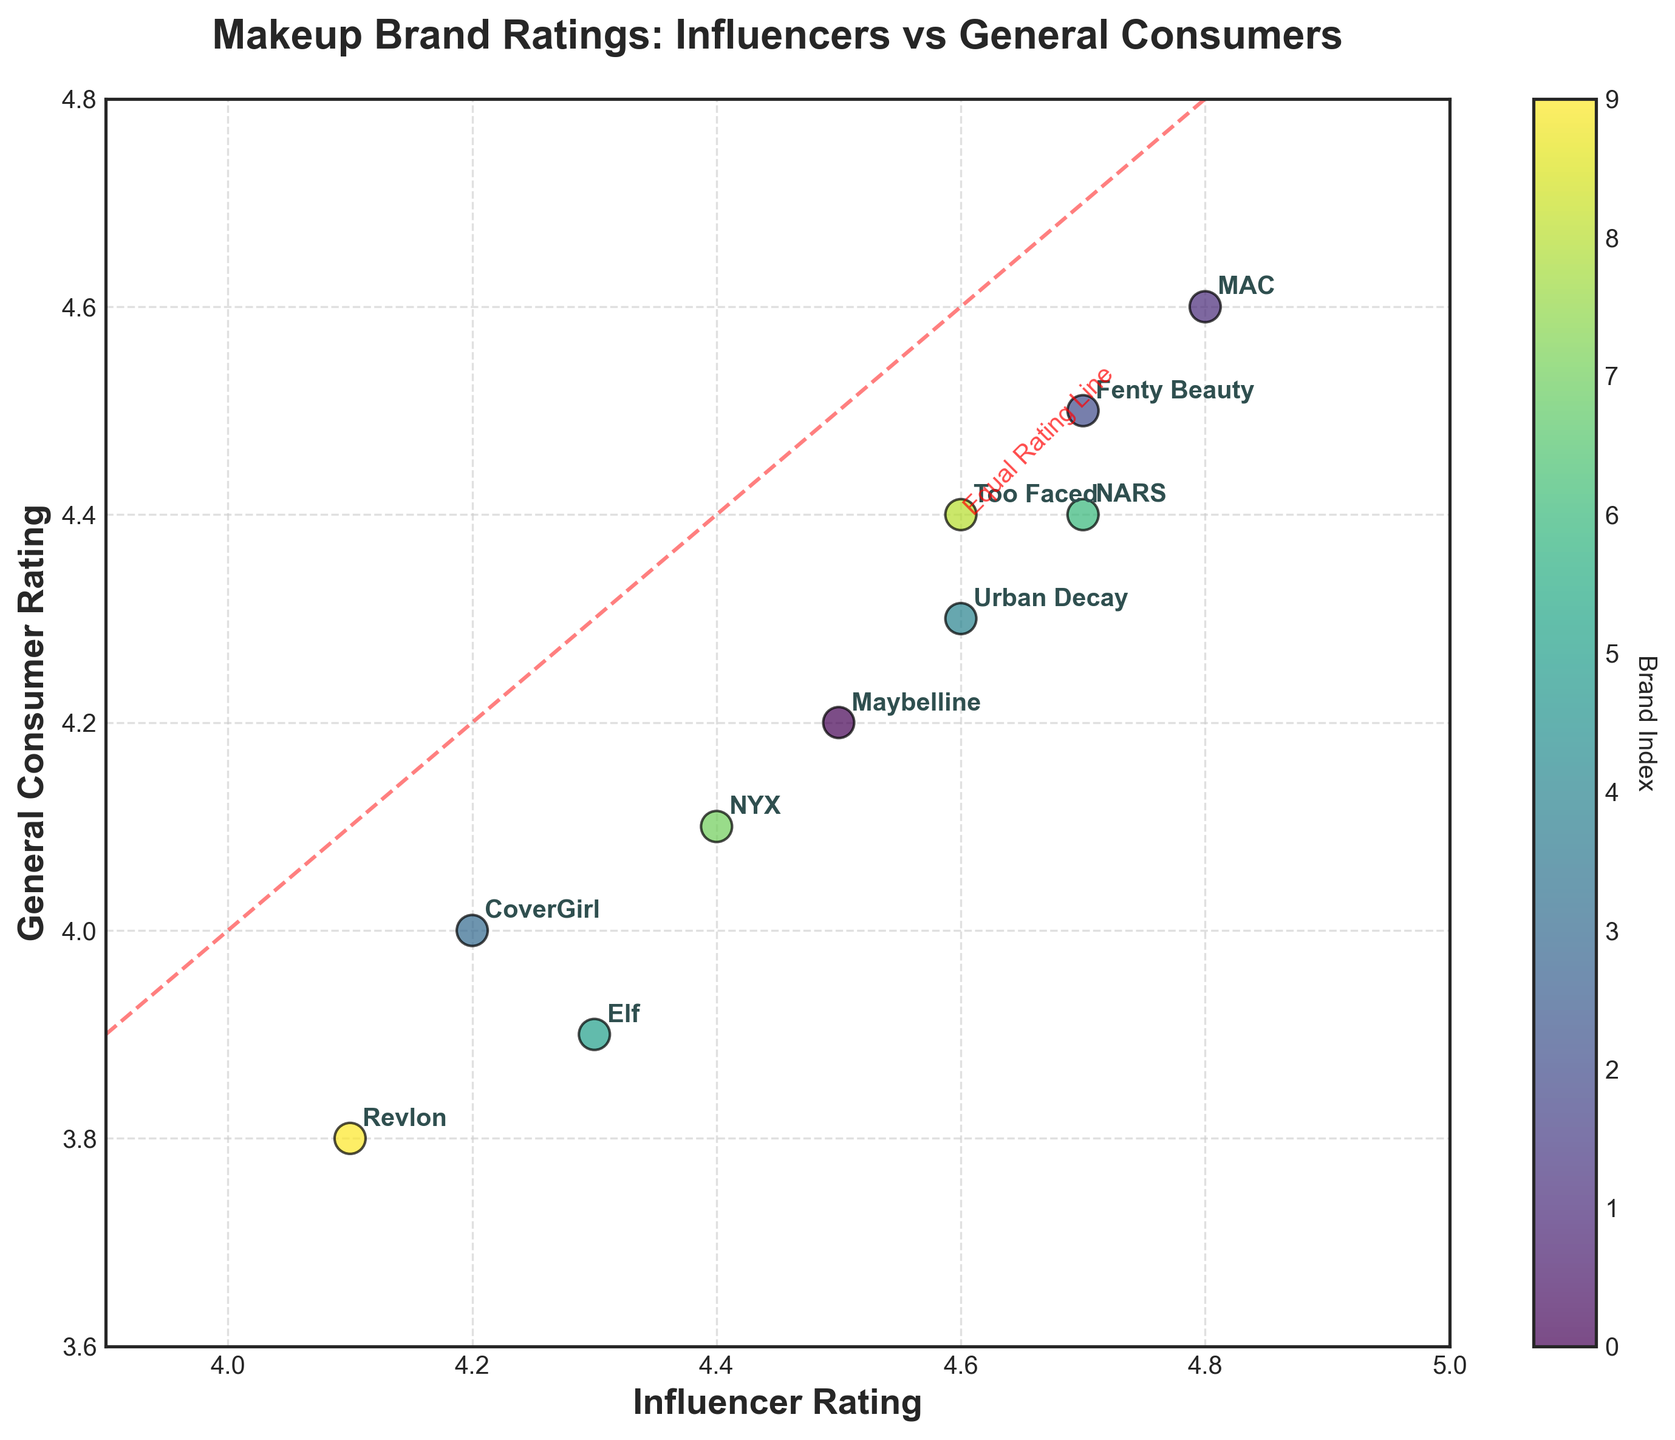What's the title of the figure? The title is usually located at the top of the figure. The title reads "Makeup Brand Ratings: Influencers vs General Consumers".
Answer: Makeup Brand Ratings: Influencers vs General Consumers How many brands are shown in the scatter plot? Each data point on the scatter plot represents a different brand. Counting all the data points and considering the number of labels, there are 10 brands.
Answer: 10 Which brand has the highest influencer rating? By looking at the x-axis values, the brand with the highest influencer rating is identified. MAC has the highest influencer rating at 4.8.
Answer: MAC Is there a brand that has the same rating from both influencers and general consumers? For a brand to have the same rating, it would need to lie exactly on the red dashed line that marks equal ratings. There are no brands lying exactly on this line, so no brand has identical ratings.
Answer: No Which brand has the largest difference between influencer rating and general consumer rating? By comparing the distances from the data points to the red dashed line (representing equal ratings), we can identify the brand with the largest difference. Revlon shows the largest disparity, with its ratings being 4.1 from influencers and 3.8 from general consumers.
Answer: Revlon What color represents the brand with the lowest general consumer rating, and which brand is it? Looking at the y-axis value, Revlon has the lowest general consumer rating, and its color on the scatter plot can be identified from the colormap. The scatter plot uses a viridis colormap, meaning Revlon would be at the cooler end of the spectrum, representing lower general consumer ratings.
Answer: Revlon, a cool color from the colormap What is the average rating given by general consumers across all brands? To find this, calculate the average of all y-axis values. Summing the values: 4.2 + 4.6 + 4.5 + 4.0 + 4.3 + 3.9 + 4.4 + 4.1 + 4.4 + 3.8 = 42.2. Dividing by the number of brands (10), the average rating is 42.2 / 10 = 4.22
Answer: 4.22 How many brands have higher influencer ratings than general consumer ratings? Checking each data point for which the x-axis value (influencer rating) is higher than the y-axis value (general consumer rating), we count the instances. Brands: Maybelline, Fenty Beauty, CoverGirl, Urban Decay, Elf, NARS, NYX, Revlon. There are 8 brands where the influencer rating is higher.
Answer: 8 Which brand has the closest ratings between influencers and general consumers? By comparing the differences between x and y values for each brand, the smallest difference will show the closest ratings. Too Faced and Fenty Beauty both have close ratings, but Too Faced has an influencer rating of 4.6 and a general consumer rating of 4.4, a difference of 0.2, same as MAC's closeness but lower.
Answer: Too Faced What's the range of influencer ratings in this plot? The range can be calculated by subtracting the minimum influencer rating from the maximum influencer rating. The minimum influencer rating is Revlon with 4.1 and the maximum is MAC with 4.8. The range is 4.8 - 4.1.
Answer: 0.7 